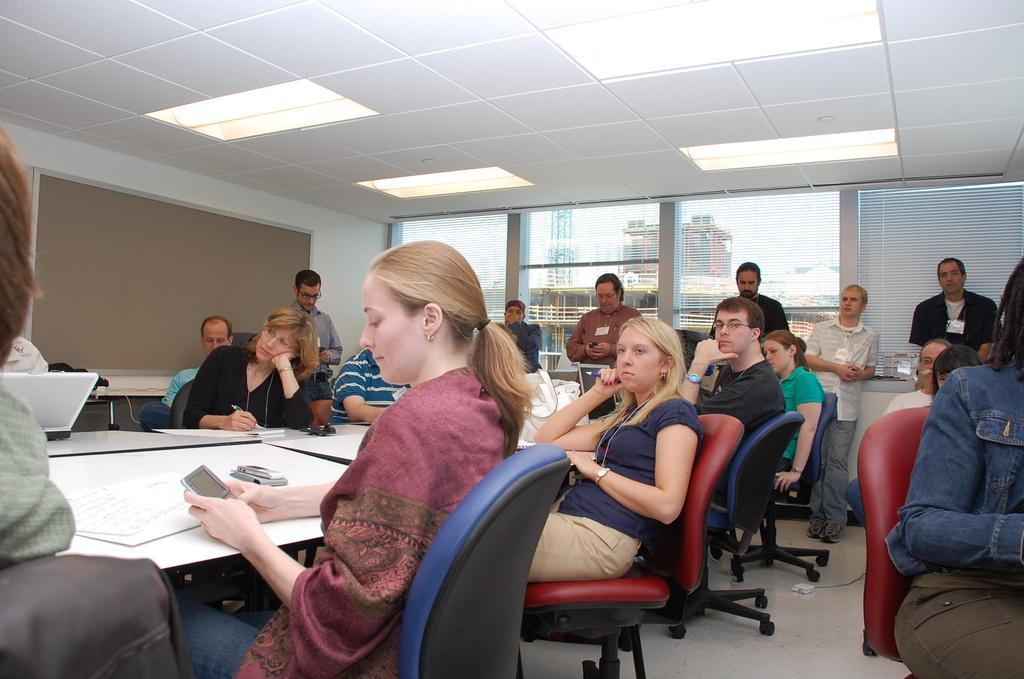What is the woman doing in the image? The woman is sitting on a chair in the image. Where is the woman located in relation to the table? The woman is around a table in the image. What can be seen in the background or surrounding area of the image? There are lights visible in the image. Can you describe the other person in the image? Yes, there is a person standing in the image. What type of brake is the woman using to stop the planes in the image? There are no planes or brakes present in the image; it features a woman sitting on a chair and a person standing nearby. How many sheep can be seen in the image? There are no sheep present in the image. 